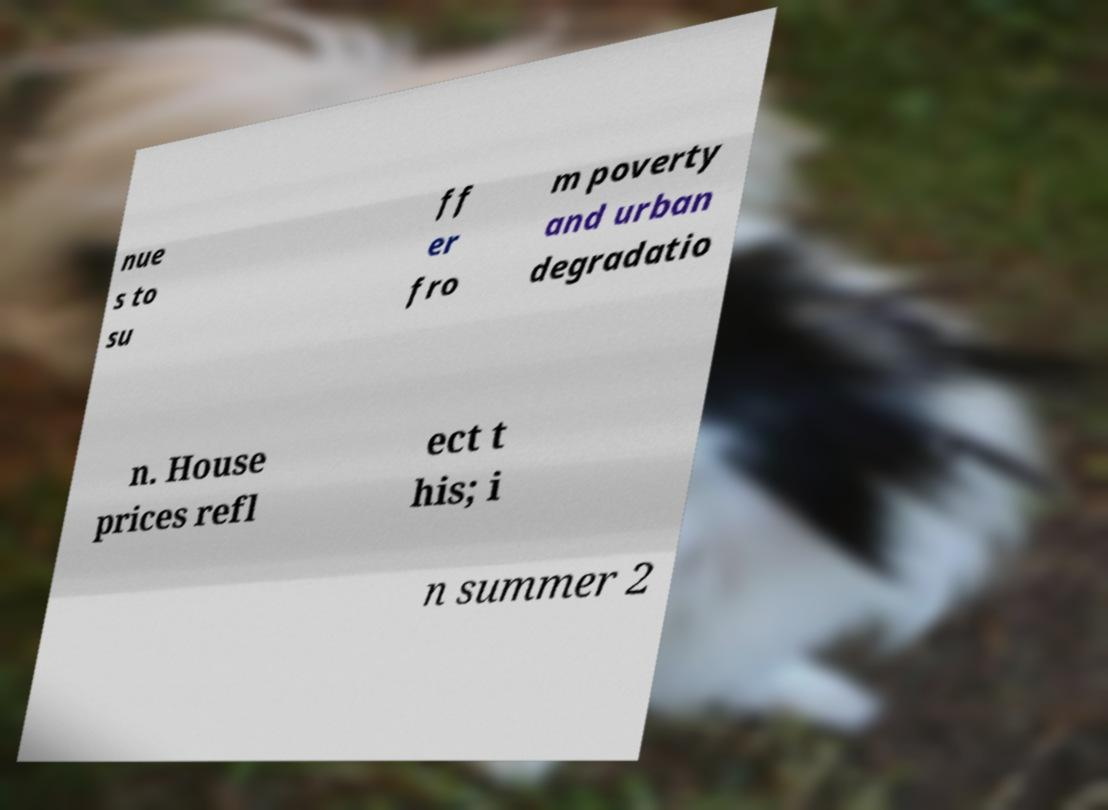Can you accurately transcribe the text from the provided image for me? nue s to su ff er fro m poverty and urban degradatio n. House prices refl ect t his; i n summer 2 